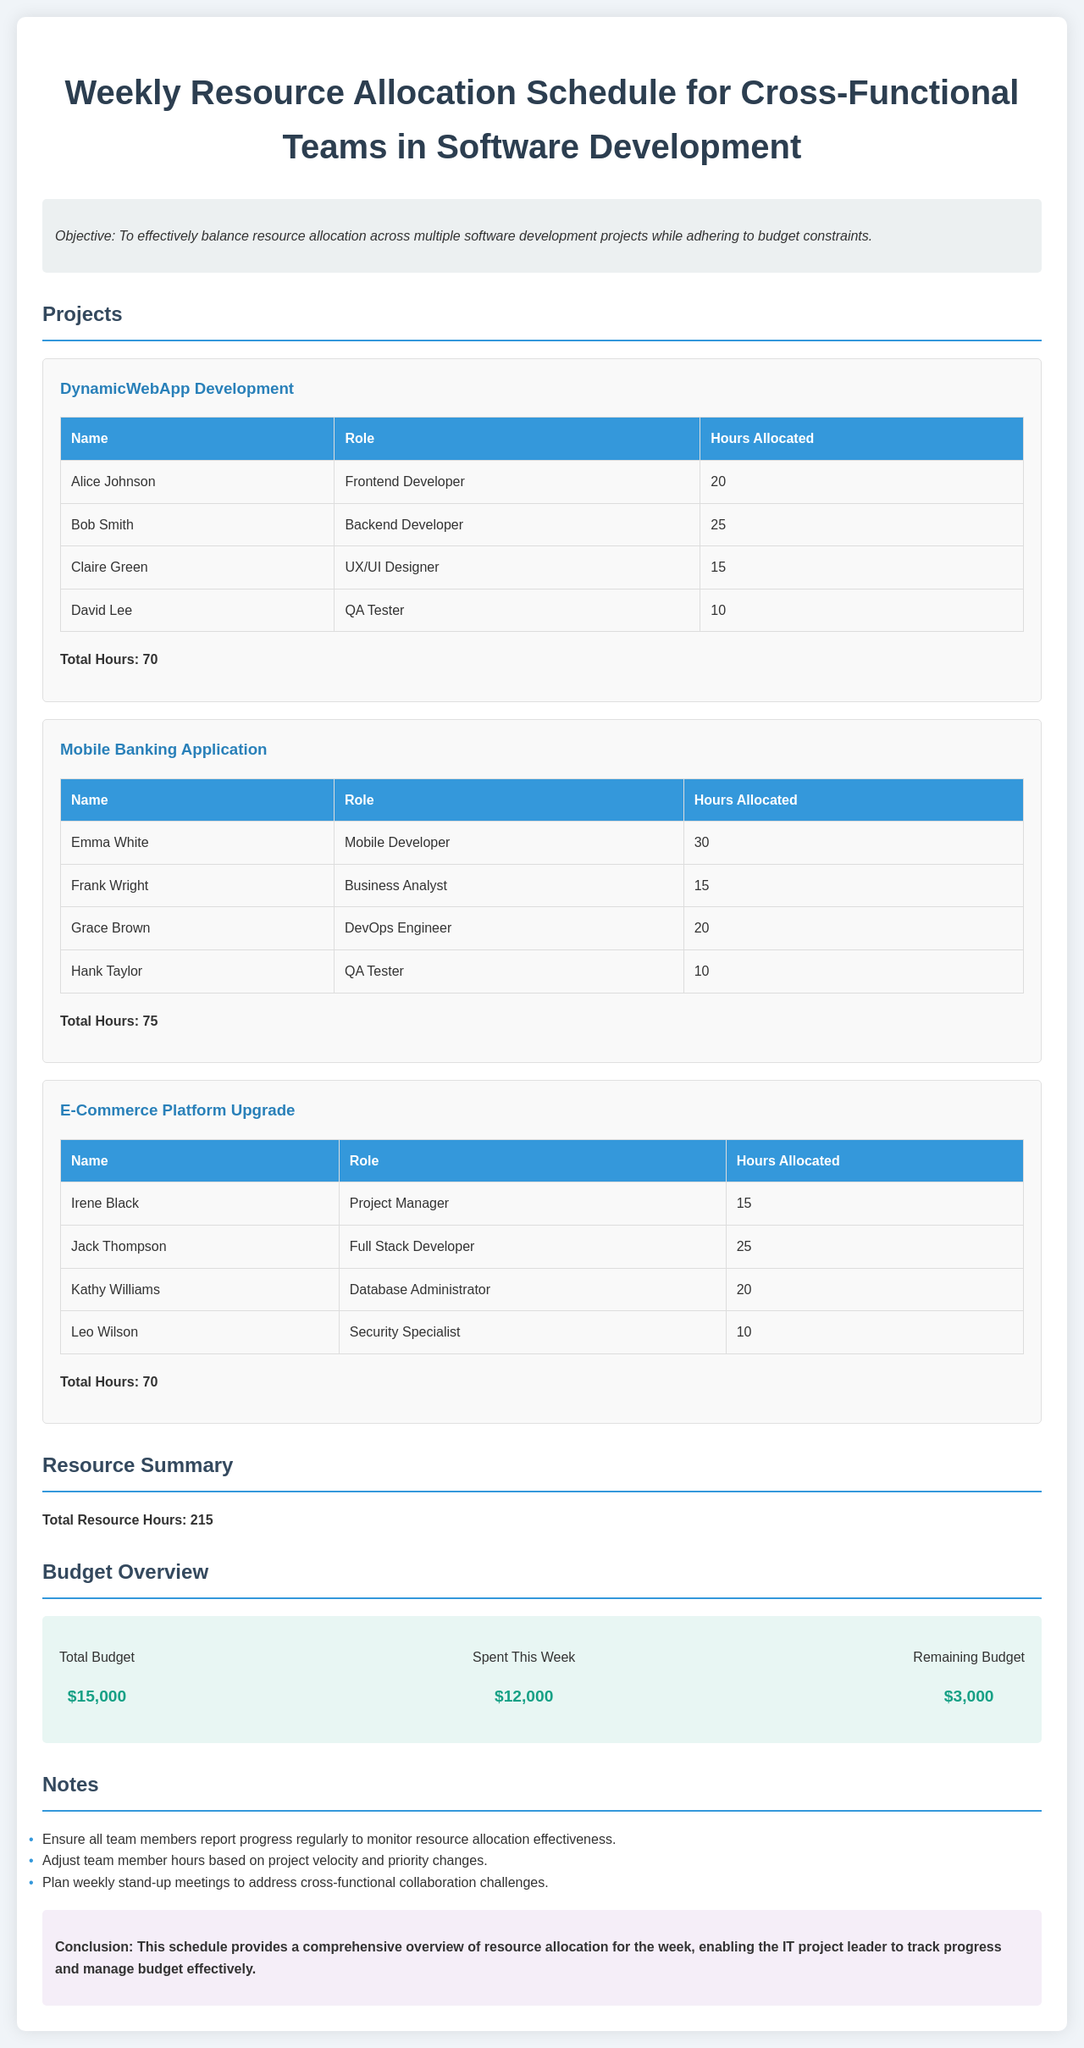What is the objective of the schedule? The objective is stated as balancing resource allocation across multiple software development projects while adhering to budget constraints.
Answer: To effectively balance resource allocation across multiple software development projects while adhering to budget constraints Who is the QA Tester for the Mobile Banking Application? The QA Tester listed for the Mobile Banking Application is Hank Taylor.
Answer: Hank Taylor How many total hours are allocated to the DynamicWebApp Development project? The total hours allocated for the DynamicWebApp Development project are provided at the end of the project section.
Answer: 70 What is the total budget available for the projects? The total budget is directly shown in the budget overview section of the document.
Answer: $15,000 How many total resource hours are allocated across all projects? The total resource hours are summarized in the Resource Summary section of the document.
Answer: 215 What role does Claire Green fill in the DynamicWebApp Development project? Claire Green's role is specified in the project table.
Answer: UX/UI Designer What is the remaining budget after expenditures this week? The remaining budget is indicated in the budget overview section.
Answer: $3,000 How many hours are allocated to Frank Wright as a Business Analyst? The hours allocated to Frank Wright are listed in the Mobile Banking Application project table.
Answer: 15 What important action is suggested regarding team members' progress? Noted in the Notes section, it emphasizes the need for team members to report progress.
Answer: Report progress regularly 